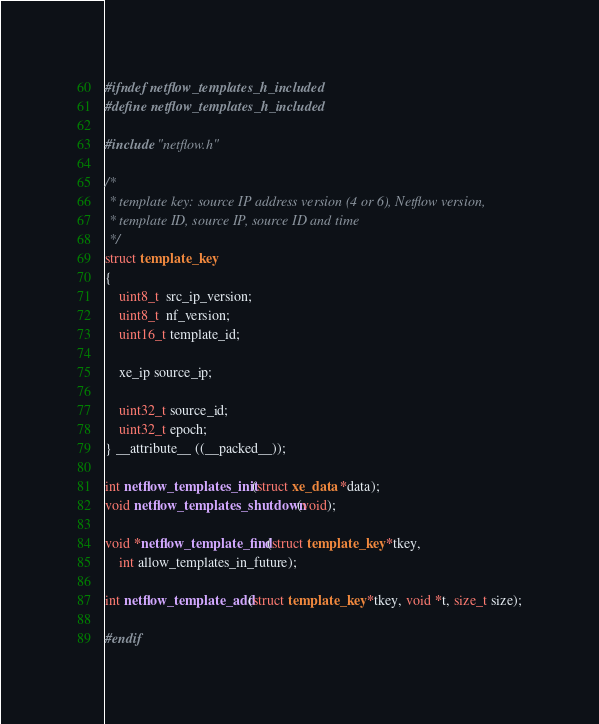Convert code to text. <code><loc_0><loc_0><loc_500><loc_500><_C_>#ifndef netflow_templates_h_included
#define netflow_templates_h_included

#include "netflow.h"

/*
 * template key: source IP address version (4 or 6), Netflow version,
 * template ID, source IP, source ID and time
 */
struct template_key
{
	uint8_t  src_ip_version;
	uint8_t  nf_version;
	uint16_t template_id;

	xe_ip source_ip;

	uint32_t source_id;
	uint32_t epoch;
} __attribute__ ((__packed__));

int netflow_templates_init(struct xe_data *data);
void netflow_templates_shutdown(void);

void *netflow_template_find(struct template_key *tkey,
	int allow_templates_in_future);

int netflow_template_add(struct template_key *tkey, void *t, size_t size);

#endif

</code> 